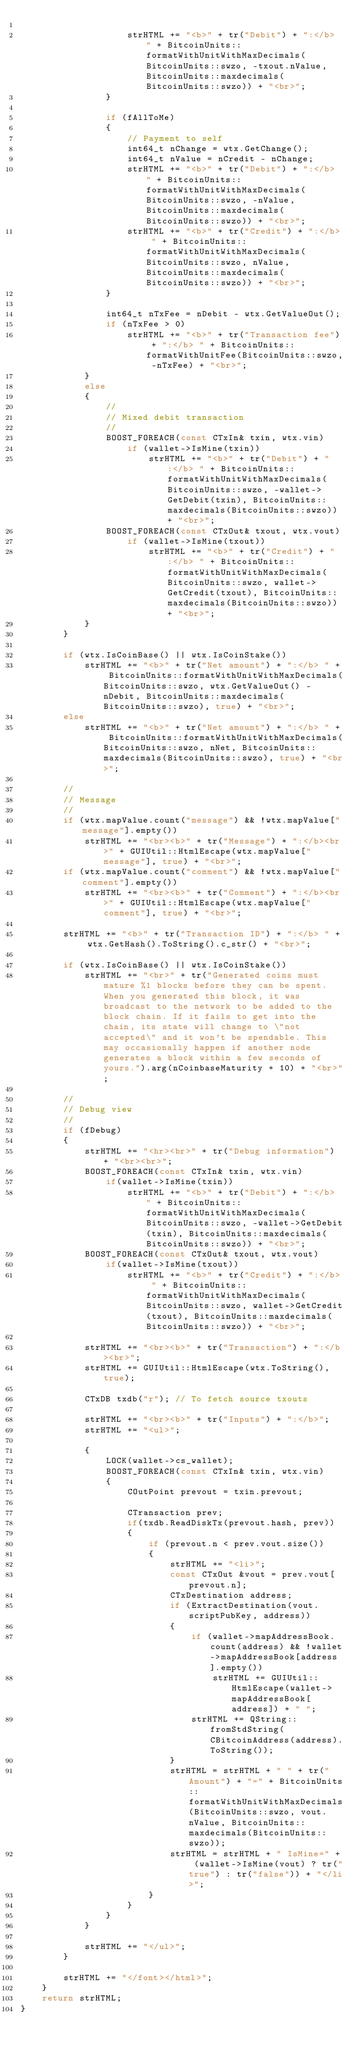<code> <loc_0><loc_0><loc_500><loc_500><_C++_>
                    strHTML += "<b>" + tr("Debit") + ":</b> " + BitcoinUnits::formatWithUnitWithMaxDecimals(BitcoinUnits::swzo, -txout.nValue, BitcoinUnits::maxdecimals(BitcoinUnits::swzo)) + "<br>";
                }

                if (fAllToMe)
                {
                    // Payment to self
                    int64_t nChange = wtx.GetChange();
                    int64_t nValue = nCredit - nChange;
                    strHTML += "<b>" + tr("Debit") + ":</b> " + BitcoinUnits::formatWithUnitWithMaxDecimals(BitcoinUnits::swzo, -nValue, BitcoinUnits::maxdecimals(BitcoinUnits::swzo)) + "<br>";
                    strHTML += "<b>" + tr("Credit") + ":</b> " + BitcoinUnits::formatWithUnitWithMaxDecimals(BitcoinUnits::swzo, nValue, BitcoinUnits::maxdecimals(BitcoinUnits::swzo)) + "<br>";
                }

                int64_t nTxFee = nDebit - wtx.GetValueOut();
                if (nTxFee > 0)
                    strHTML += "<b>" + tr("Transaction fee") + ":</b> " + BitcoinUnits::formatWithUnitFee(BitcoinUnits::swzo, -nTxFee) + "<br>";
            }
            else
            {
                //
                // Mixed debit transaction
                //
                BOOST_FOREACH(const CTxIn& txin, wtx.vin)
                    if (wallet->IsMine(txin))
                        strHTML += "<b>" + tr("Debit") + ":</b> " + BitcoinUnits::formatWithUnitWithMaxDecimals(BitcoinUnits::swzo, -wallet->GetDebit(txin), BitcoinUnits::maxdecimals(BitcoinUnits::swzo)) + "<br>";
                BOOST_FOREACH(const CTxOut& txout, wtx.vout)
                    if (wallet->IsMine(txout))
                        strHTML += "<b>" + tr("Credit") + ":</b> " + BitcoinUnits::formatWithUnitWithMaxDecimals(BitcoinUnits::swzo, wallet->GetCredit(txout), BitcoinUnits::maxdecimals(BitcoinUnits::swzo)) + "<br>";
            }
        }

        if (wtx.IsCoinBase() || wtx.IsCoinStake())
            strHTML += "<b>" + tr("Net amount") + ":</b> " + BitcoinUnits::formatWithUnitWithMaxDecimals(BitcoinUnits::swzo, wtx.GetValueOut() - nDebit, BitcoinUnits::maxdecimals(BitcoinUnits::swzo), true) + "<br>";
        else
            strHTML += "<b>" + tr("Net amount") + ":</b> " + BitcoinUnits::formatWithUnitWithMaxDecimals(BitcoinUnits::swzo, nNet, BitcoinUnits::maxdecimals(BitcoinUnits::swzo), true) + "<br>";

        //
        // Message
        //
        if (wtx.mapValue.count("message") && !wtx.mapValue["message"].empty())
            strHTML += "<br><b>" + tr("Message") + ":</b><br>" + GUIUtil::HtmlEscape(wtx.mapValue["message"], true) + "<br>";
        if (wtx.mapValue.count("comment") && !wtx.mapValue["comment"].empty())
            strHTML += "<br><b>" + tr("Comment") + ":</b><br>" + GUIUtil::HtmlEscape(wtx.mapValue["comment"], true) + "<br>";

        strHTML += "<b>" + tr("Transaction ID") + ":</b> " + wtx.GetHash().ToString().c_str() + "<br>";

        if (wtx.IsCoinBase() || wtx.IsCoinStake())
            strHTML += "<br>" + tr("Generated coins must mature %1 blocks before they can be spent. When you generated this block, it was broadcast to the network to be added to the block chain. If it fails to get into the chain, its state will change to \"not accepted\" and it won't be spendable. This may occasionally happen if another node generates a block within a few seconds of yours.").arg(nCoinbaseMaturity + 10) + "<br>";

        //
        // Debug view
        //
        if (fDebug)
        {
            strHTML += "<hr><br>" + tr("Debug information") + "<br><br>";
            BOOST_FOREACH(const CTxIn& txin, wtx.vin)
                if(wallet->IsMine(txin))
                    strHTML += "<b>" + tr("Debit") + ":</b> " + BitcoinUnits::formatWithUnitWithMaxDecimals(BitcoinUnits::swzo, -wallet->GetDebit(txin), BitcoinUnits::maxdecimals(BitcoinUnits::swzo)) + "<br>";
            BOOST_FOREACH(const CTxOut& txout, wtx.vout)
                if(wallet->IsMine(txout))
                    strHTML += "<b>" + tr("Credit") + ":</b> " + BitcoinUnits::formatWithUnitWithMaxDecimals(BitcoinUnits::swzo, wallet->GetCredit(txout), BitcoinUnits::maxdecimals(BitcoinUnits::swzo)) + "<br>";

            strHTML += "<br><b>" + tr("Transaction") + ":</b><br>";
            strHTML += GUIUtil::HtmlEscape(wtx.ToString(), true);

            CTxDB txdb("r"); // To fetch source txouts

            strHTML += "<br><b>" + tr("Inputs") + ":</b>";
            strHTML += "<ul>";

            {
                LOCK(wallet->cs_wallet);
                BOOST_FOREACH(const CTxIn& txin, wtx.vin)
                {
                    COutPoint prevout = txin.prevout;

                    CTransaction prev;
                    if(txdb.ReadDiskTx(prevout.hash, prev))
                    {
                        if (prevout.n < prev.vout.size())
                        {
                            strHTML += "<li>";
                            const CTxOut &vout = prev.vout[prevout.n];
                            CTxDestination address;
                            if (ExtractDestination(vout.scriptPubKey, address))
                            {
                                if (wallet->mapAddressBook.count(address) && !wallet->mapAddressBook[address].empty())
                                    strHTML += GUIUtil::HtmlEscape(wallet->mapAddressBook[address]) + " ";
                                strHTML += QString::fromStdString(CBitcoinAddress(address).ToString());
                            }
                            strHTML = strHTML + " " + tr("Amount") + "=" + BitcoinUnits::formatWithUnitWithMaxDecimals(BitcoinUnits::swzo, vout.nValue, BitcoinUnits::maxdecimals(BitcoinUnits::swzo));
                            strHTML = strHTML + " IsMine=" + (wallet->IsMine(vout) ? tr("true") : tr("false")) + "</li>";
                        }
                    }
                }
            }

            strHTML += "</ul>";
        }

        strHTML += "</font></html>";
    }
    return strHTML;
}
</code> 